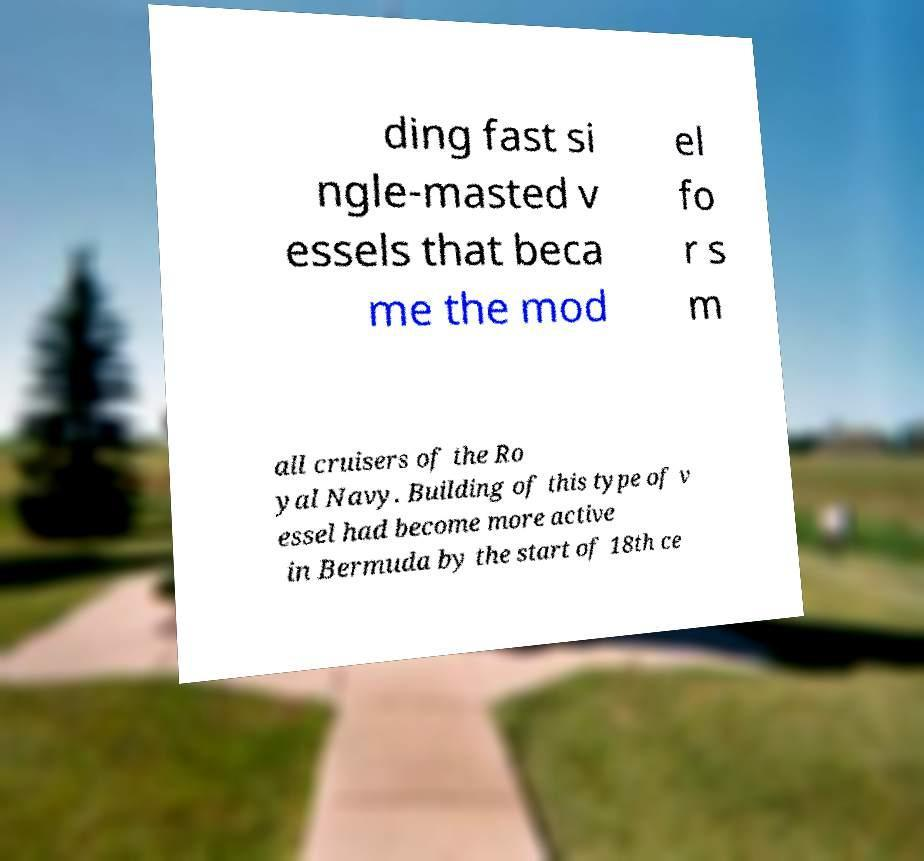What messages or text are displayed in this image? I need them in a readable, typed format. ding fast si ngle-masted v essels that beca me the mod el fo r s m all cruisers of the Ro yal Navy. Building of this type of v essel had become more active in Bermuda by the start of 18th ce 